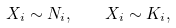Convert formula to latex. <formula><loc_0><loc_0><loc_500><loc_500>X _ { i } \sim N _ { i } , \quad X _ { i } \sim K _ { i } ,</formula> 